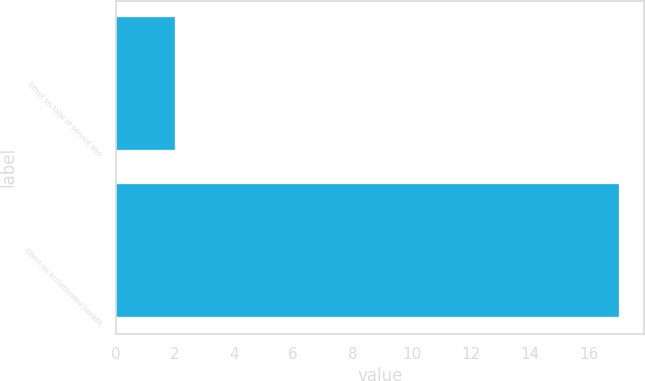<chart> <loc_0><loc_0><loc_500><loc_500><bar_chart><fcel>Effect on total of service and<fcel>Effect on accumulated benefit<nl><fcel>2<fcel>17<nl></chart> 